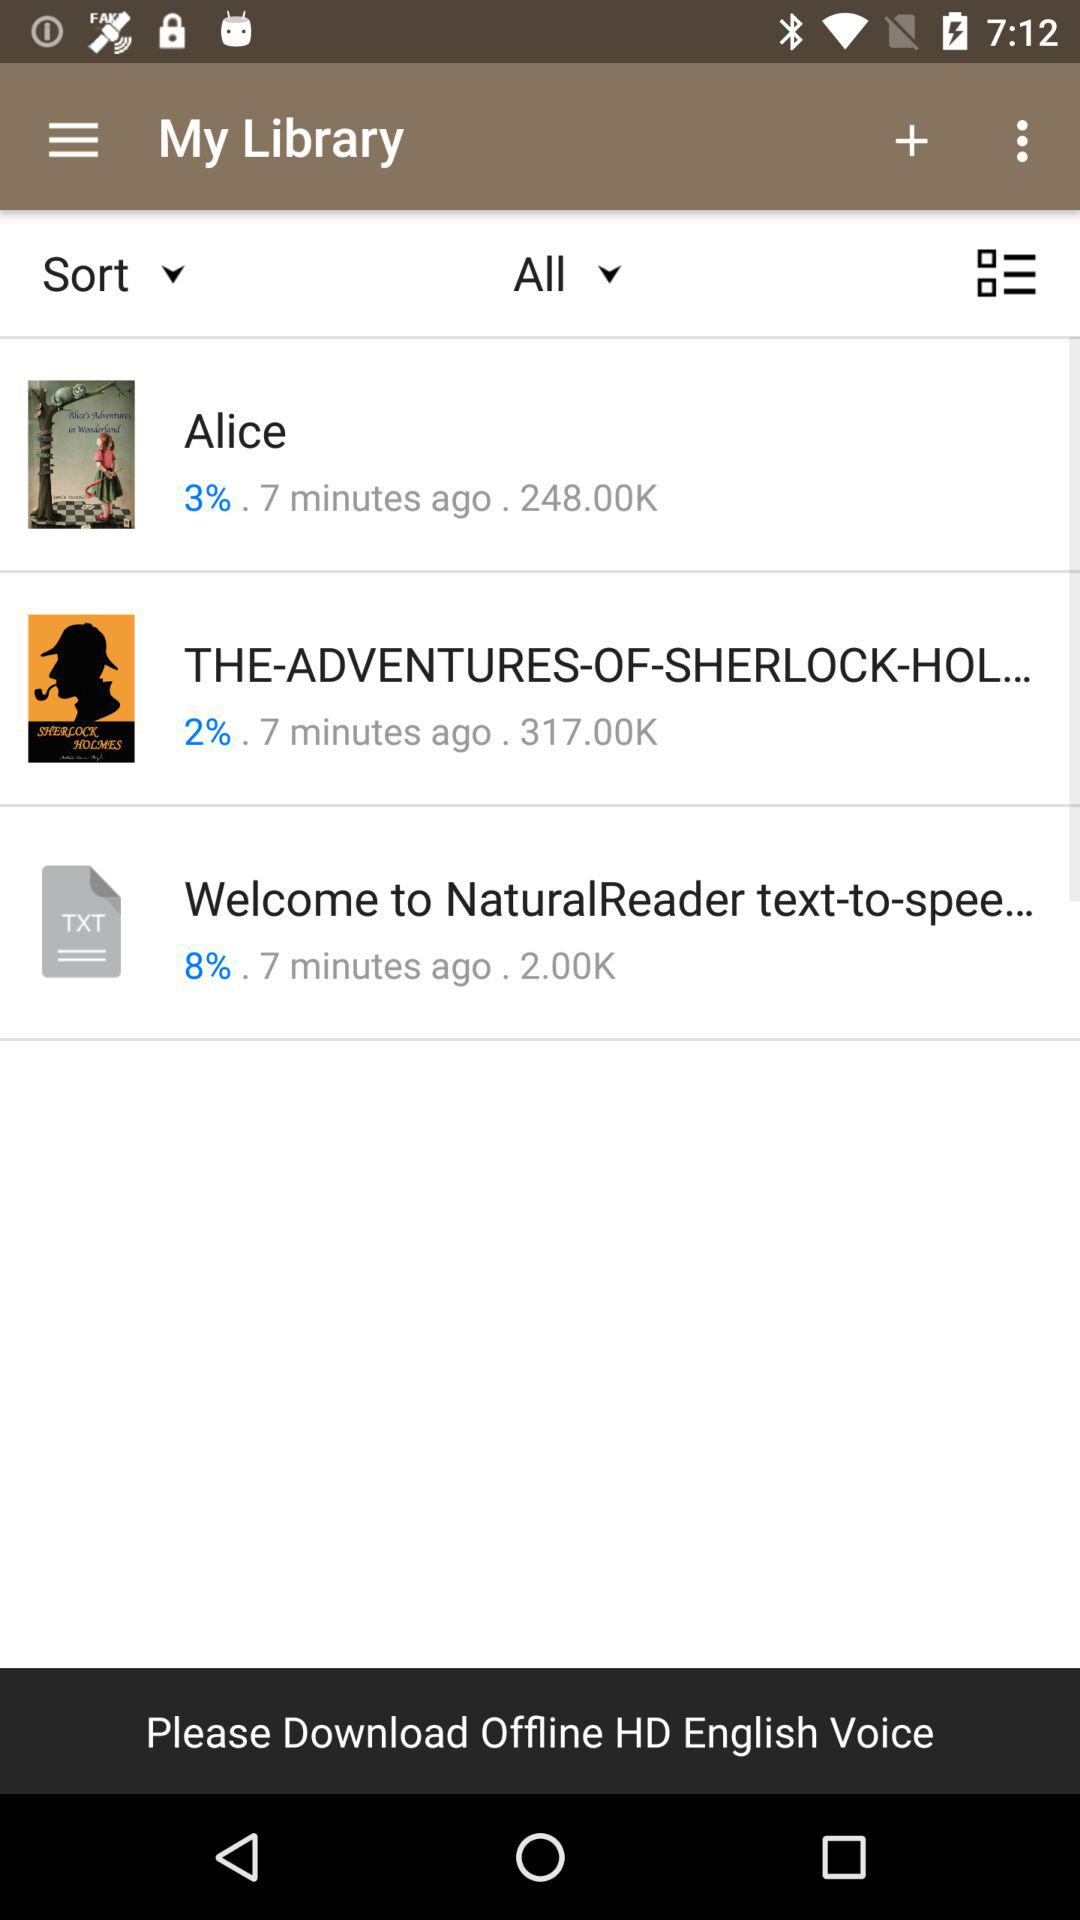What percentage of the Alice was downloaded? The percentage was 3. 